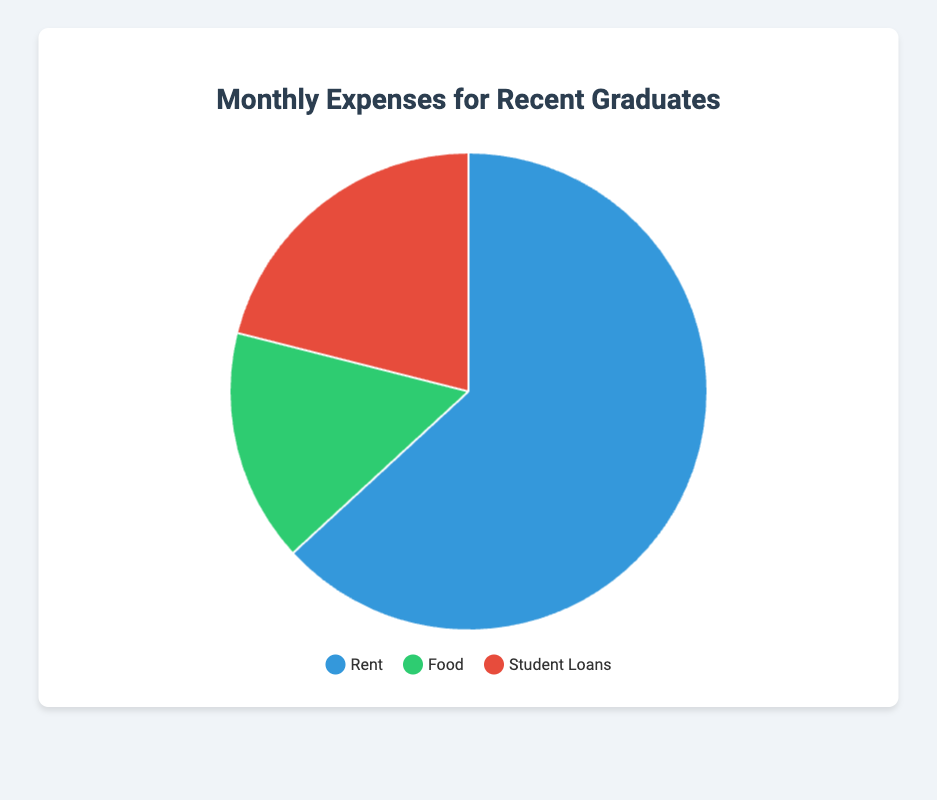Which category has the highest expense? The pie chart shows three categories: Rent, Food, and Student Loans. Rent has the largest section. The amount for Rent is also the highest at $1200.
Answer: Rent What's the total monthly expense? To find the total monthly expense, sum the amounts for Rent, Food, and Student Loans: $1200 (Rent) + $300 (Food) + $400 (Student Loans) = $1900.
Answer: $1900 How much more is spent on Rent compared to Student Loans? Subtract the amount spent on Student Loans from the amount spent on Rent: $1200 (Rent) - $400 (Student Loans) = $800.
Answer: $800 What is the percentage of total monthly expenses spent on Food? The total monthly expenses are $1900. The amount spent on Food is $300. To find the percentage, divide the amount spent on Food by the total expenses and multiply by 100: ($300 / $1900) * 100 ≈ 15.79%.
Answer: 15.79% Is the amount spent on Food and Student Loans together greater than the amount spent on Rent? Sum the amounts spent on Food and Student Loans: $300 (Food) + $400 (Student Loans) = $700. Compare this with the amount spent on Rent, which is $1200. Since $700 < $1200, the combined amount for Food and Student Loans is not greater than the amount for Rent.
Answer: No Which category has the smallest expense? The pie chart indicates that Food has the smallest section. The amount spent on Food is the lowest at $300.
Answer: Food By how much does the expense on Rent exceed the combined expenses of Food and Student Loans? First, sum the amounts for Food and Student Loans: $300 (Food) + $400 (Student Loans) = $700. Then, subtract this sum from the amount spent on Rent: $1200 (Rent) - $700 = $500.
Answer: $500 What fraction of the total monthly expenses is spent on Rent? The total monthly expenses are $1900, and the amount spent on Rent is $1200. To find the fraction, divide the amount spent on Rent by the total expenses: $1200 / $1900 ≈ 0.6316. This fraction can be roughly expressed as 63.16%.
Answer: 0.6316 / 63.16% What color represents the Student Loans category in the pie chart? The color assigned to Student Loans in the chart is red, as indicated by the associated sector color in the legend.
Answer: Red 